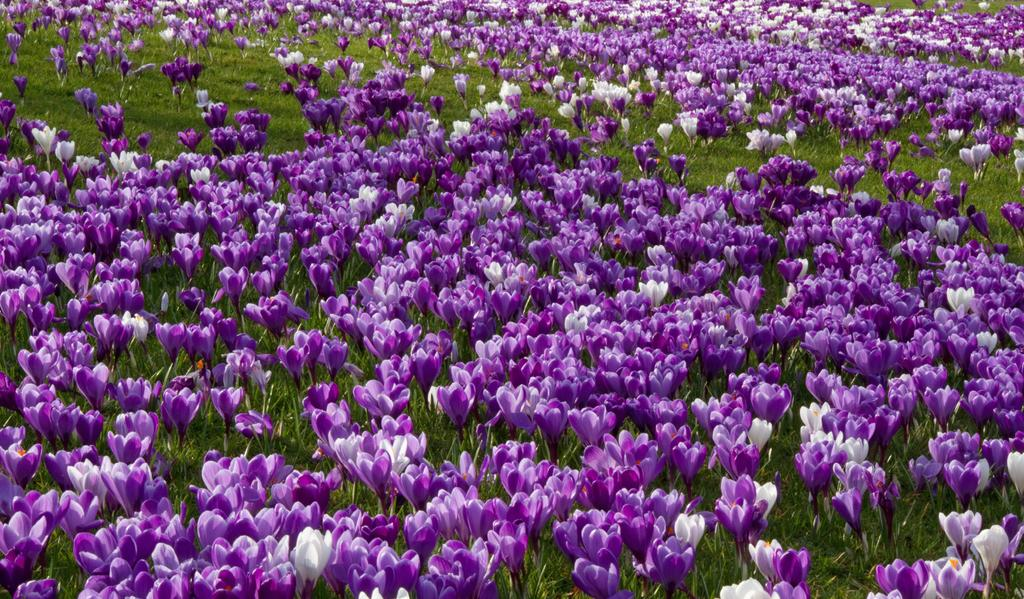What type of plants can be seen in the image? There are flowers in the image. What color are the flowers in the image? The flowers are purple in color. What type of vegetation is visible at the bottom of the image? There is green grass visible at the bottom of the image. How does the flower support the ring in the image? There is no ring present in the image, and therefore no such interaction can be observed. 